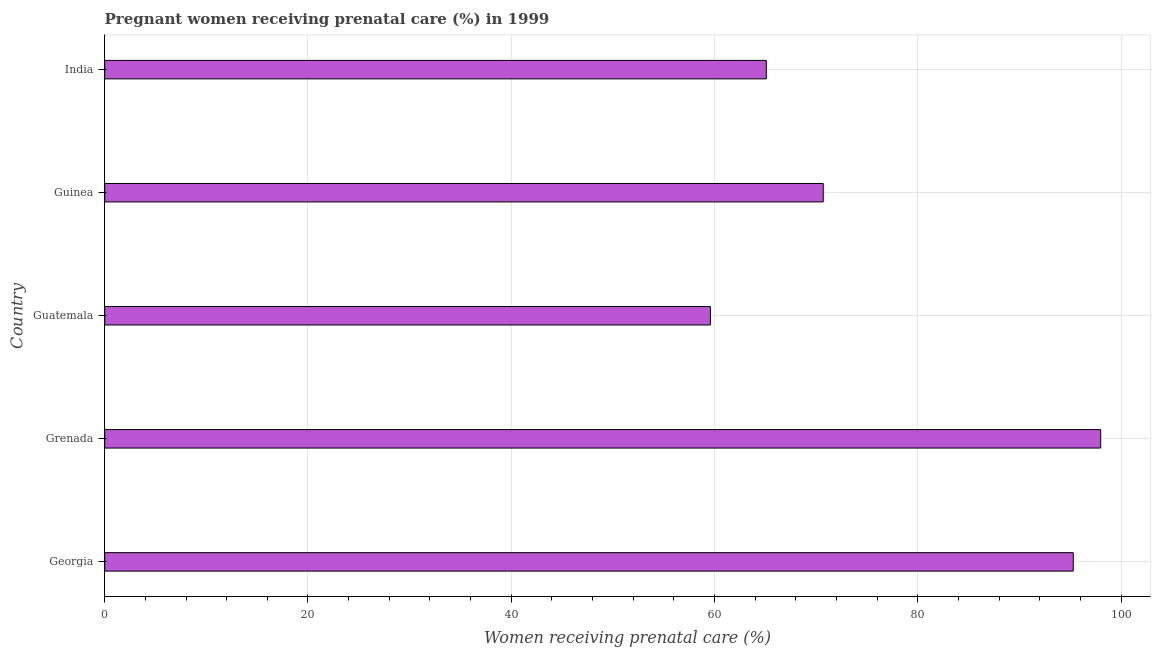Does the graph contain any zero values?
Make the answer very short. No. What is the title of the graph?
Offer a very short reply. Pregnant women receiving prenatal care (%) in 1999. What is the label or title of the X-axis?
Keep it short and to the point. Women receiving prenatal care (%). What is the percentage of pregnant women receiving prenatal care in Guinea?
Keep it short and to the point. 70.7. Across all countries, what is the minimum percentage of pregnant women receiving prenatal care?
Your answer should be compact. 59.6. In which country was the percentage of pregnant women receiving prenatal care maximum?
Provide a succinct answer. Grenada. In which country was the percentage of pregnant women receiving prenatal care minimum?
Provide a succinct answer. Guatemala. What is the sum of the percentage of pregnant women receiving prenatal care?
Your response must be concise. 388.7. What is the average percentage of pregnant women receiving prenatal care per country?
Your answer should be very brief. 77.74. What is the median percentage of pregnant women receiving prenatal care?
Give a very brief answer. 70.7. What is the ratio of the percentage of pregnant women receiving prenatal care in Guatemala to that in Guinea?
Your response must be concise. 0.84. Is the sum of the percentage of pregnant women receiving prenatal care in Grenada and Guatemala greater than the maximum percentage of pregnant women receiving prenatal care across all countries?
Make the answer very short. Yes. What is the difference between the highest and the lowest percentage of pregnant women receiving prenatal care?
Make the answer very short. 38.4. In how many countries, is the percentage of pregnant women receiving prenatal care greater than the average percentage of pregnant women receiving prenatal care taken over all countries?
Your answer should be very brief. 2. How many bars are there?
Your answer should be very brief. 5. How many countries are there in the graph?
Provide a short and direct response. 5. What is the Women receiving prenatal care (%) of Georgia?
Provide a succinct answer. 95.3. What is the Women receiving prenatal care (%) of Grenada?
Provide a short and direct response. 98. What is the Women receiving prenatal care (%) of Guatemala?
Make the answer very short. 59.6. What is the Women receiving prenatal care (%) in Guinea?
Offer a terse response. 70.7. What is the Women receiving prenatal care (%) of India?
Provide a short and direct response. 65.1. What is the difference between the Women receiving prenatal care (%) in Georgia and Guatemala?
Provide a short and direct response. 35.7. What is the difference between the Women receiving prenatal care (%) in Georgia and Guinea?
Keep it short and to the point. 24.6. What is the difference between the Women receiving prenatal care (%) in Georgia and India?
Offer a very short reply. 30.2. What is the difference between the Women receiving prenatal care (%) in Grenada and Guatemala?
Ensure brevity in your answer.  38.4. What is the difference between the Women receiving prenatal care (%) in Grenada and Guinea?
Make the answer very short. 27.3. What is the difference between the Women receiving prenatal care (%) in Grenada and India?
Offer a very short reply. 32.9. What is the difference between the Women receiving prenatal care (%) in Guatemala and India?
Give a very brief answer. -5.5. What is the ratio of the Women receiving prenatal care (%) in Georgia to that in Guatemala?
Your answer should be very brief. 1.6. What is the ratio of the Women receiving prenatal care (%) in Georgia to that in Guinea?
Offer a terse response. 1.35. What is the ratio of the Women receiving prenatal care (%) in Georgia to that in India?
Provide a short and direct response. 1.46. What is the ratio of the Women receiving prenatal care (%) in Grenada to that in Guatemala?
Your response must be concise. 1.64. What is the ratio of the Women receiving prenatal care (%) in Grenada to that in Guinea?
Make the answer very short. 1.39. What is the ratio of the Women receiving prenatal care (%) in Grenada to that in India?
Keep it short and to the point. 1.5. What is the ratio of the Women receiving prenatal care (%) in Guatemala to that in Guinea?
Provide a short and direct response. 0.84. What is the ratio of the Women receiving prenatal care (%) in Guatemala to that in India?
Offer a terse response. 0.92. What is the ratio of the Women receiving prenatal care (%) in Guinea to that in India?
Your answer should be very brief. 1.09. 